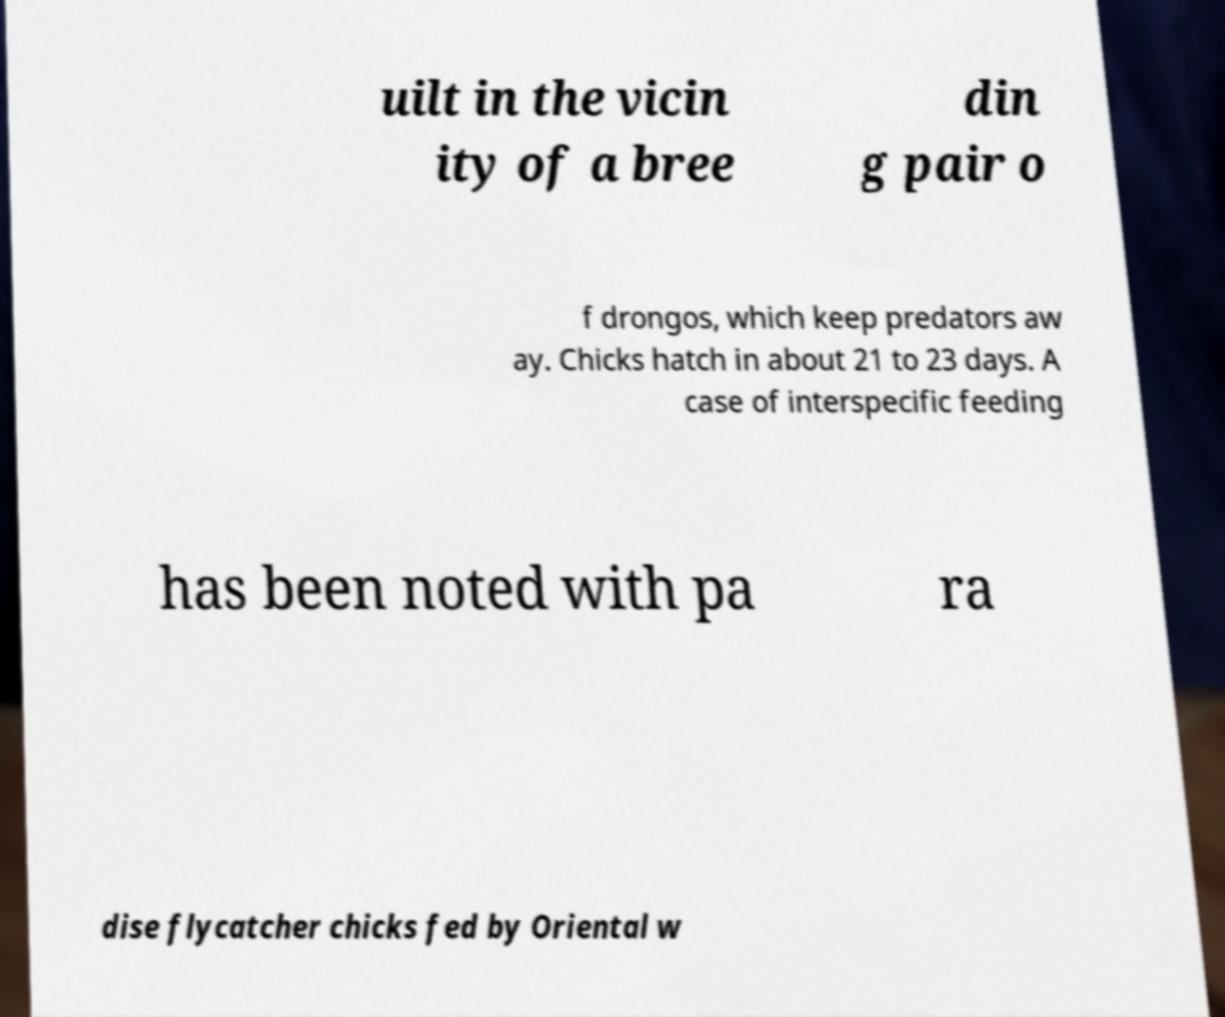Could you extract and type out the text from this image? uilt in the vicin ity of a bree din g pair o f drongos, which keep predators aw ay. Chicks hatch in about 21 to 23 days. A case of interspecific feeding has been noted with pa ra dise flycatcher chicks fed by Oriental w 